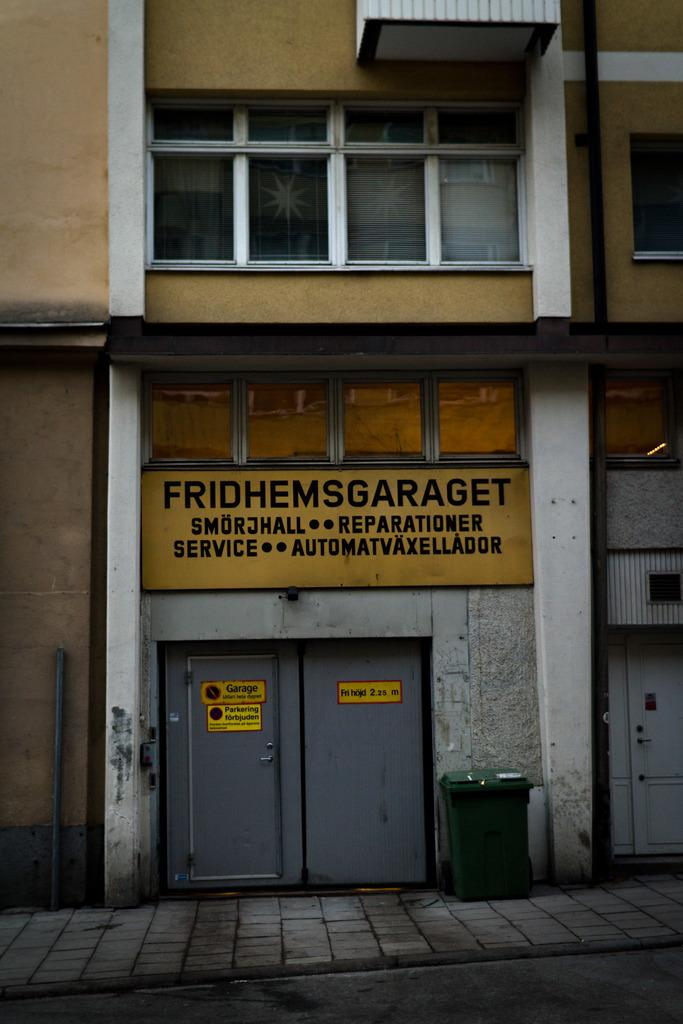What structure is the main focus of the image? There is a building in the image. What object is located in front of the building? There is a dustbin in front of the building. What can be seen in the middle of the image? There is a hoarding in the middle of the image. What is written or displayed on the hoarding? There is text on the hoarding. How many beggars are visible in the image? There are no beggars present in the image. What type of lamp is hanging from the building in the image? There is no lamp hanging from the building in the image. 